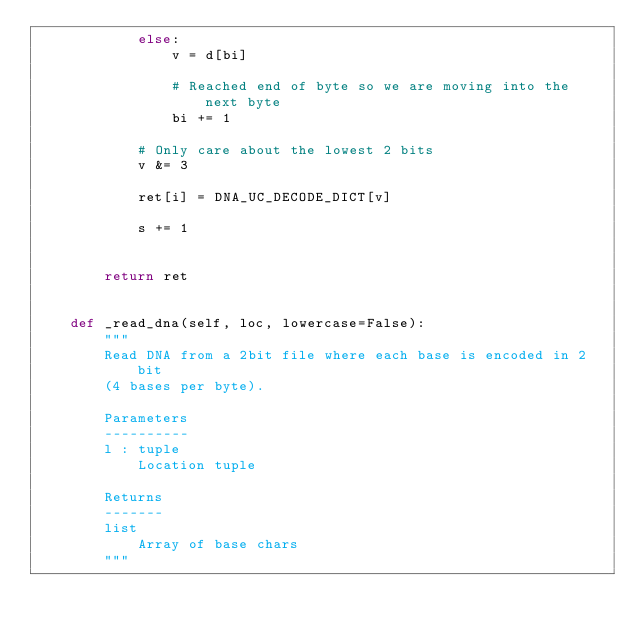Convert code to text. <code><loc_0><loc_0><loc_500><loc_500><_Python_>            else:
                v = d[bi]
                
                # Reached end of byte so we are moving into the next byte
                bi += 1
            
            # Only care about the lowest 2 bits
            v &= 3
            
            ret[i] = DNA_UC_DECODE_DICT[v]
                
            s += 1

  
        return ret
    
    
    def _read_dna(self, loc, lowercase=False):
        """
        Read DNA from a 2bit file where each base is encoded in 2bit 
        (4 bases per byte).
        
        Parameters
        ----------
        l : tuple
            Location tuple
        
        Returns
        -------
        list
            Array of base chars
        """
        </code> 